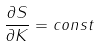<formula> <loc_0><loc_0><loc_500><loc_500>\frac { \partial S } { \partial K } = c o n s t</formula> 